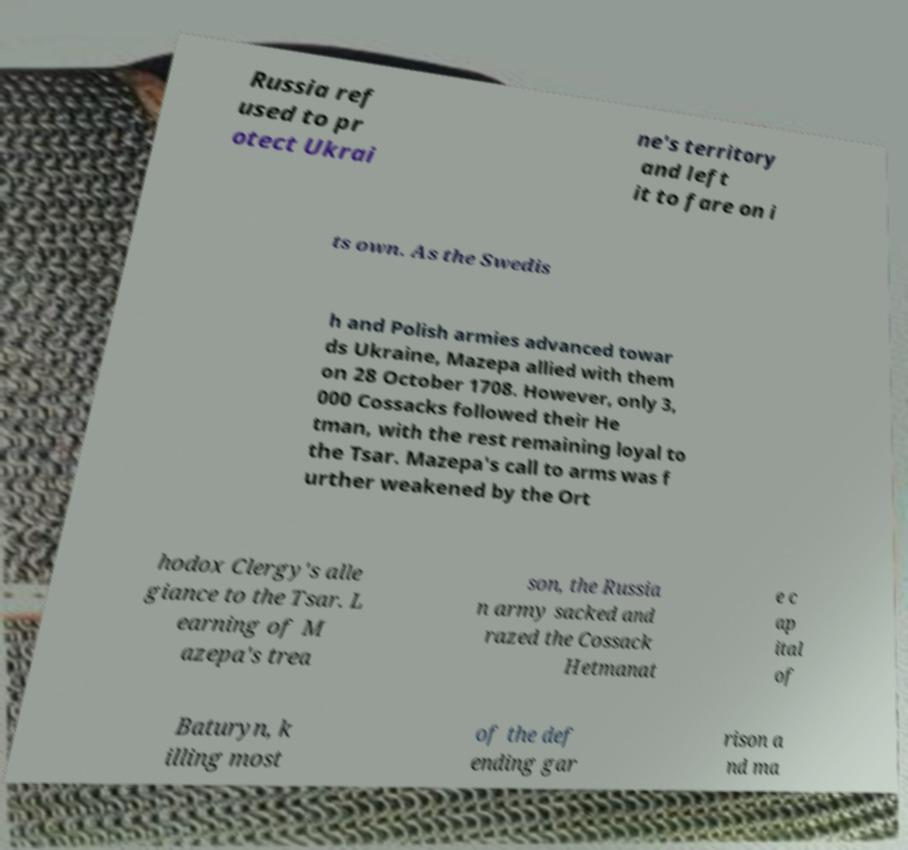Could you assist in decoding the text presented in this image and type it out clearly? Russia ref used to pr otect Ukrai ne's territory and left it to fare on i ts own. As the Swedis h and Polish armies advanced towar ds Ukraine, Mazepa allied with them on 28 October 1708. However, only 3, 000 Cossacks followed their He tman, with the rest remaining loyal to the Tsar. Mazepa's call to arms was f urther weakened by the Ort hodox Clergy's alle giance to the Tsar. L earning of M azepa's trea son, the Russia n army sacked and razed the Cossack Hetmanat e c ap ital of Baturyn, k illing most of the def ending gar rison a nd ma 